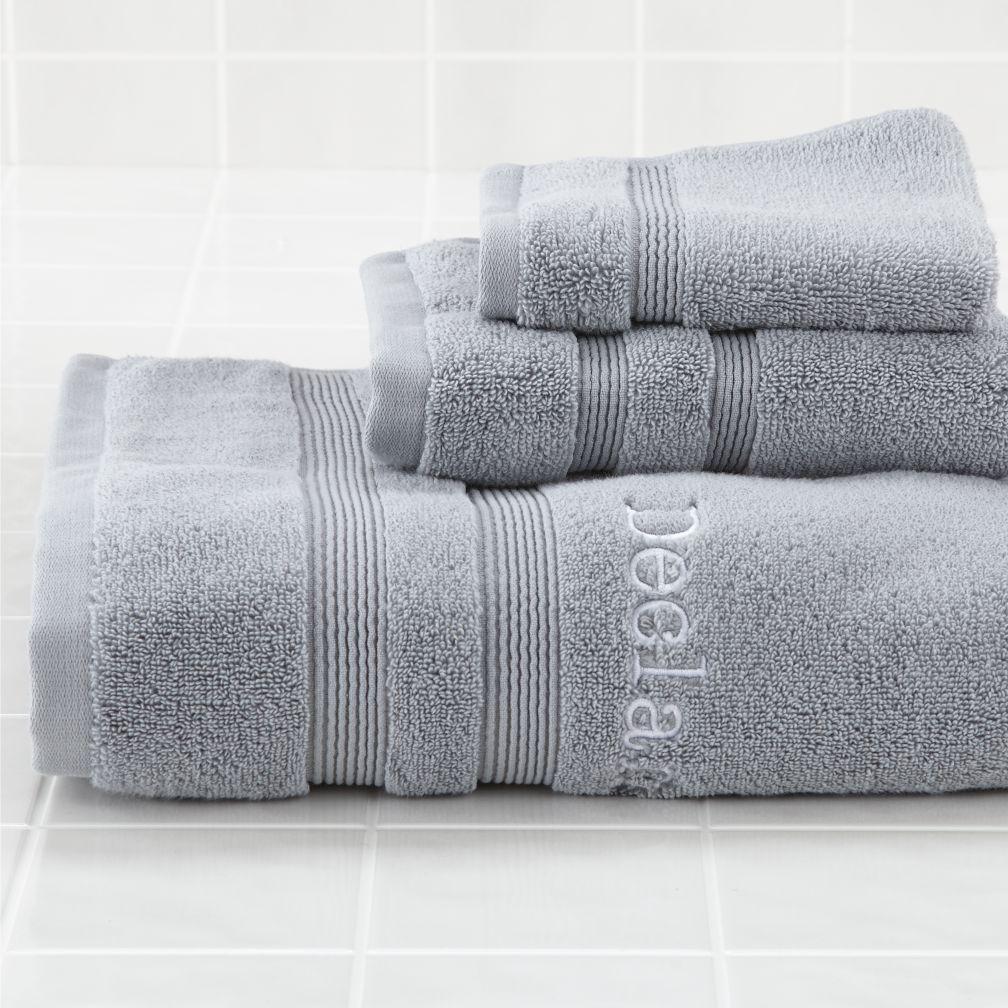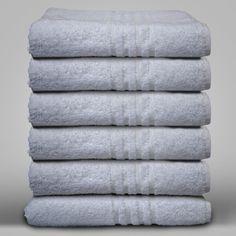The first image is the image on the left, the second image is the image on the right. Evaluate the accuracy of this statement regarding the images: "There are more items in the left image than in the right image.". Is it true? Answer yes or no. No. The first image is the image on the left, the second image is the image on the right. Examine the images to the left and right. Is the description "The left and right image contains a total of nine towels." accurate? Answer yes or no. Yes. 